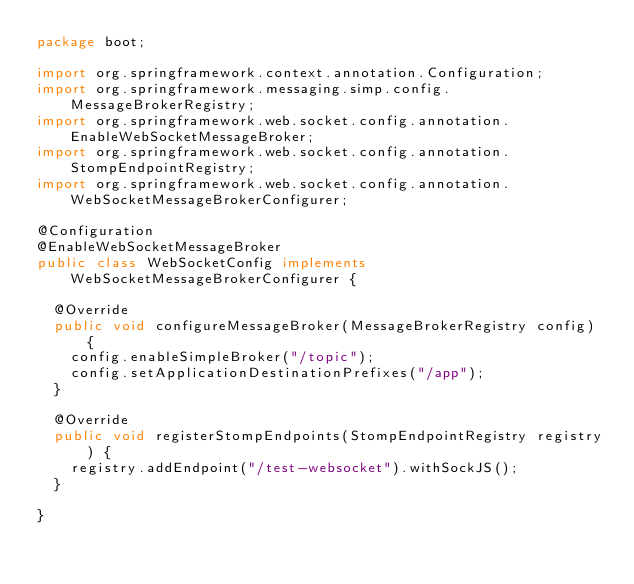<code> <loc_0><loc_0><loc_500><loc_500><_Java_>package boot;

import org.springframework.context.annotation.Configuration;
import org.springframework.messaging.simp.config.MessageBrokerRegistry;
import org.springframework.web.socket.config.annotation.EnableWebSocketMessageBroker;
import org.springframework.web.socket.config.annotation.StompEndpointRegistry;
import org.springframework.web.socket.config.annotation.WebSocketMessageBrokerConfigurer;

@Configuration
@EnableWebSocketMessageBroker
public class WebSocketConfig implements WebSocketMessageBrokerConfigurer {

  @Override
  public void configureMessageBroker(MessageBrokerRegistry config) {
    config.enableSimpleBroker("/topic");
    config.setApplicationDestinationPrefixes("/app");
  }

  @Override
  public void registerStompEndpoints(StompEndpointRegistry registry) {
    registry.addEndpoint("/test-websocket").withSockJS();
  }

}</code> 